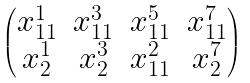Convert formula to latex. <formula><loc_0><loc_0><loc_500><loc_500>\begin{pmatrix} x _ { 1 1 } ^ { 1 } & x _ { 1 1 } ^ { 3 } & x _ { 1 1 } ^ { 5 } & x _ { 1 1 } ^ { 7 } \\ x _ { 2 } ^ { 1 } & x _ { 2 } ^ { 3 } & x _ { 1 1 } ^ { 2 } & x _ { 2 } ^ { 7 } \end{pmatrix}</formula> 